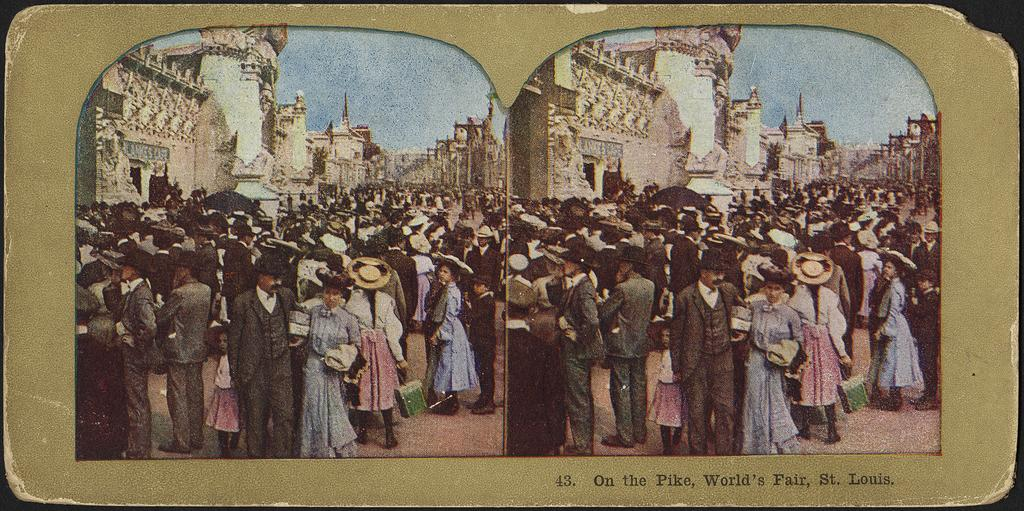<image>
Render a clear and concise summary of the photo. A picture of many people at the World's Fair in St. Louis. 